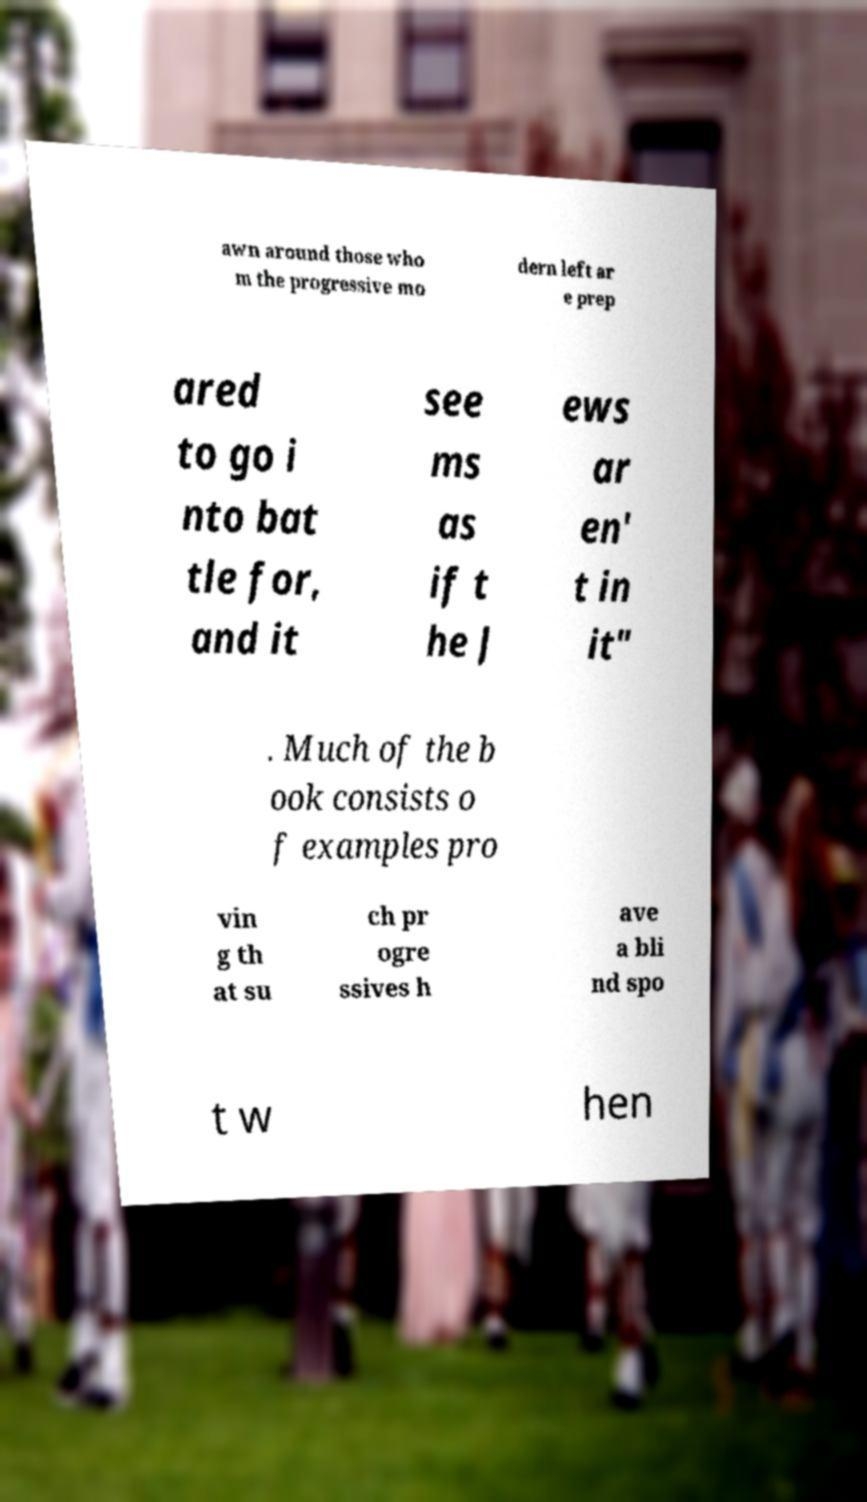Can you accurately transcribe the text from the provided image for me? awn around those who m the progressive mo dern left ar e prep ared to go i nto bat tle for, and it see ms as if t he J ews ar en' t in it" . Much of the b ook consists o f examples pro vin g th at su ch pr ogre ssives h ave a bli nd spo t w hen 